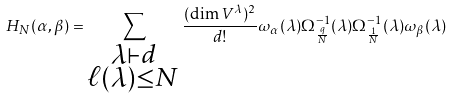Convert formula to latex. <formula><loc_0><loc_0><loc_500><loc_500>H _ { N } ( \alpha , \beta ) = \sum _ { \substack { \lambda \vdash d \\ \ell ( \lambda ) \leq N } } \frac { ( \dim V ^ { \lambda } ) ^ { 2 } } { d ! } \omega _ { \alpha } ( \lambda ) \Omega _ { \frac { q } { N } } ^ { - 1 } ( \lambda ) \Omega _ { \frac { 1 } { N } } ^ { - 1 } ( \lambda ) \omega _ { \beta } ( \lambda )</formula> 